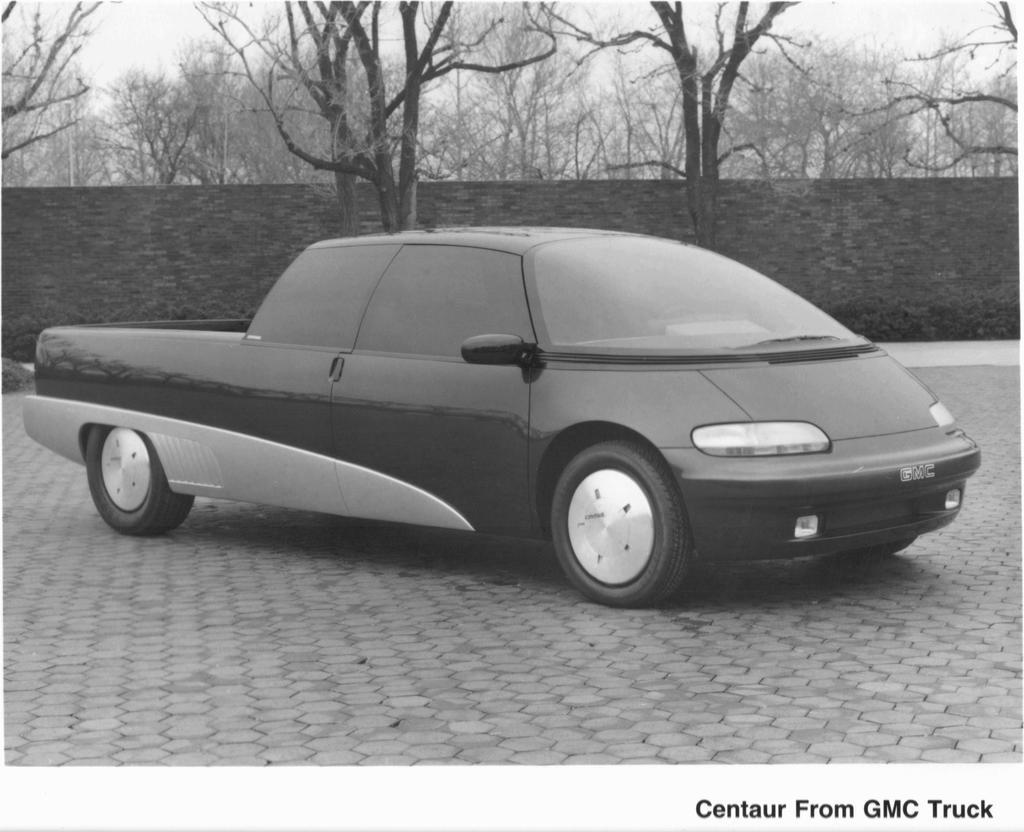What is the color scheme of the image? The image is black and white. What can be seen on the road in the image? There is a vehicle on the road in the image. What type of vegetation is visible in the background of the image? There are bare trees in the background of the image. What else can be seen in the background of the image? There is a wall and the sky visible in the background of the image. What type of head is visible on the vehicle in the image? There is no head visible on the vehicle in the image, as it is a black and white image of a vehicle on the road. What answer can be seen written on the wall in the image? There is no answer written on the wall in the image, as it is a black and white image of a vehicle on the road with a background of bare trees, a wall, and the sky. 